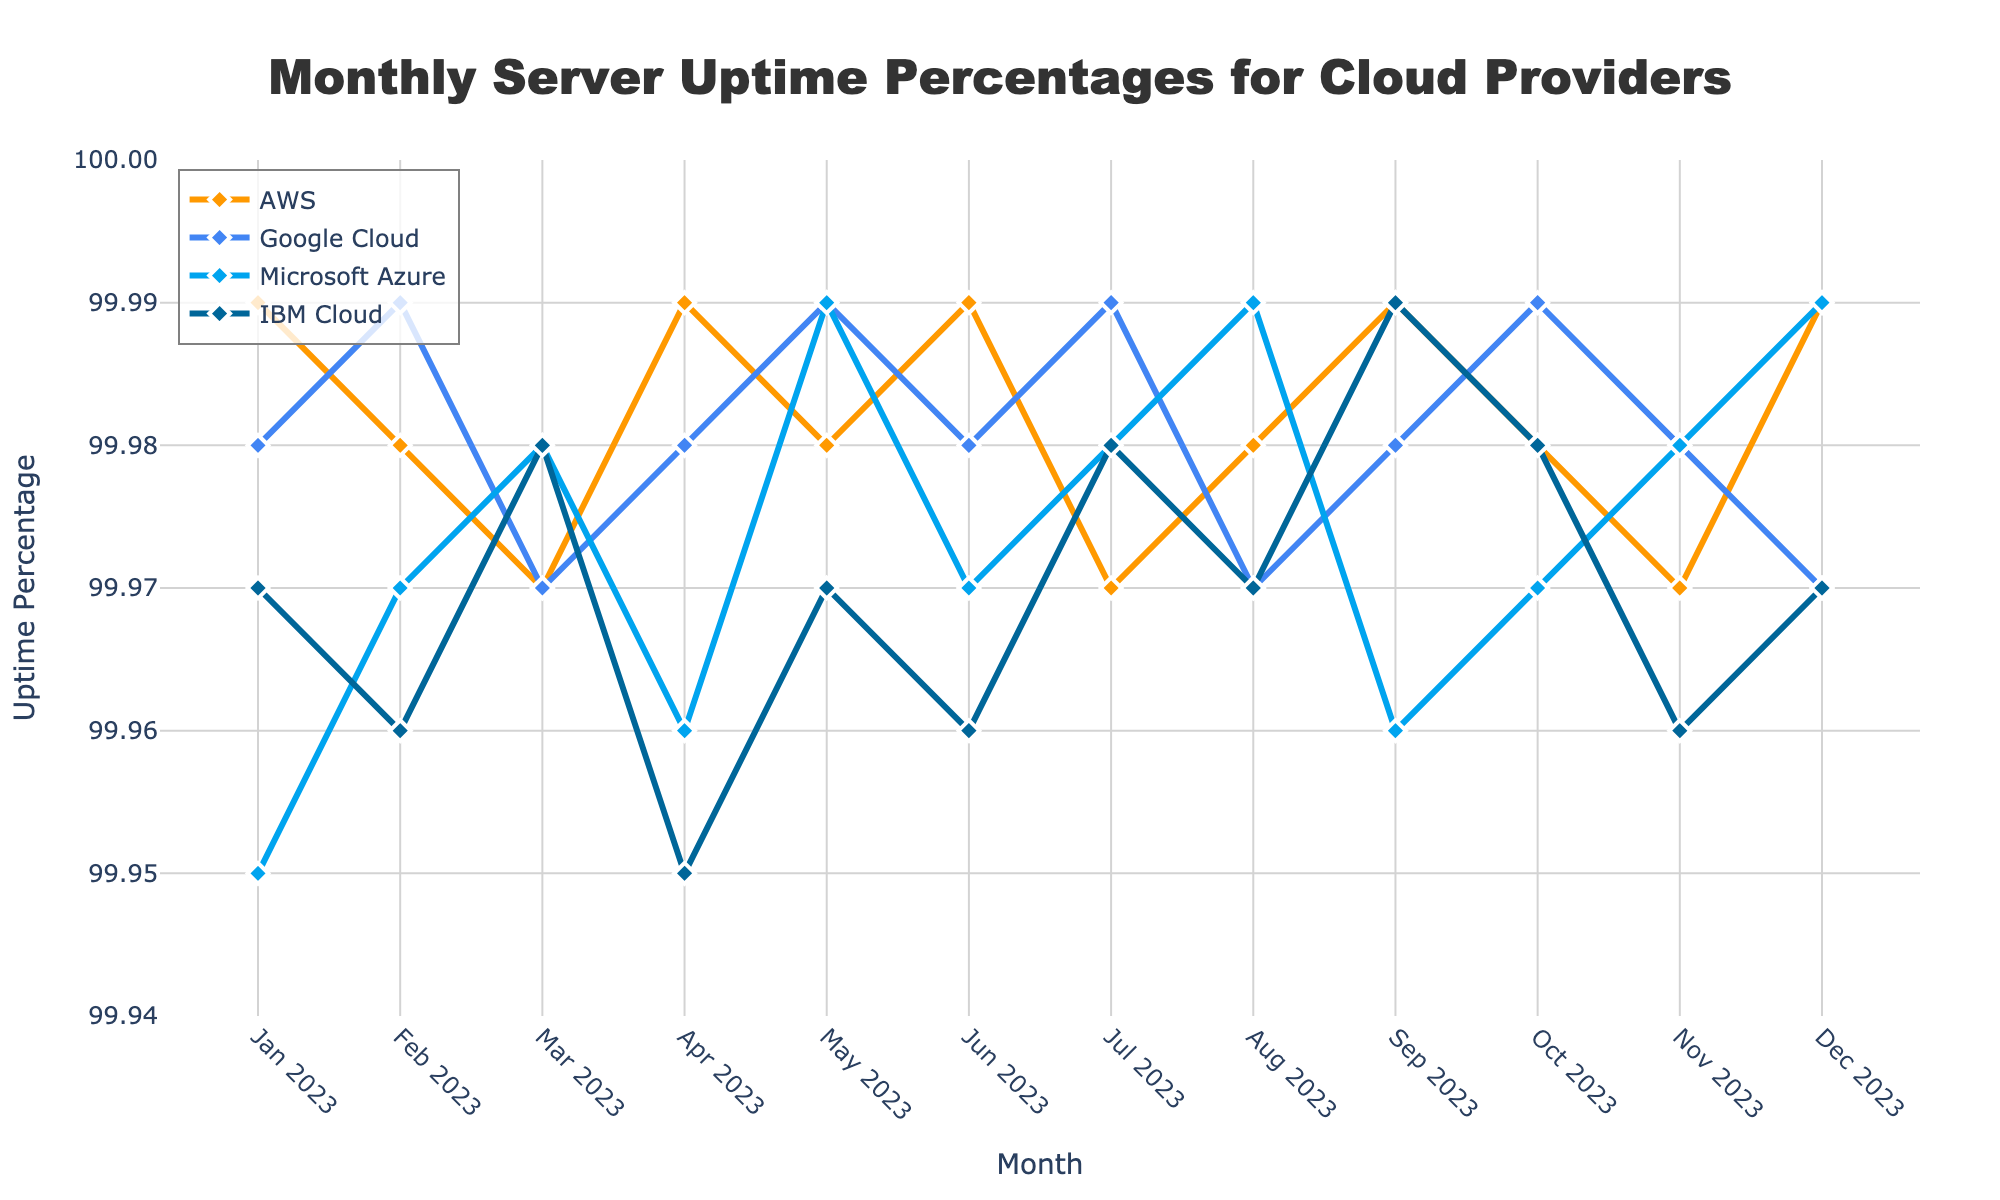What's the highest uptime percentage achieved by Google Cloud? To determine the highest uptime percentage for Google Cloud, visually inspect the plot for the peak point on the Google Cloud line (blue color). According to the dataset, Google Cloud achieved 99.99% uptime in Feb, May, Jul, and Oct of 2023.
Answer: 99.99% Which provider had the highest uptime in January 2023? Look for the January 2023 data points and compare the values of all providers. AWS had an uptime of 99.99%, Google Cloud had 99.98%, Microsoft Azure had 99.95%, and IBM Cloud had 99.97%. AWS had the highest uptime in January 2023.
Answer: AWS Between August and November 2023, which provider showed the greatest decrease in uptime? Check the uptime percentages for each provider from August to November. AWS went from 99.98% to 99.97%, Google Cloud went from 99.97% to 99.98%, Microsoft Azure went from 99.99% to 99.98%, and IBM Cloud went from 99.97% to 99.96%. AWS and IBM Cloud both showed a decrease of 0.01% in uptime.
Answer: AWS and IBM Cloud What was the average uptime percentage for AWS throughout the year? Calculate the average by summing all the monthly uptime percentages for AWS and dividing by the number of months. Sum = 99.99 + 99.98 + 99.97 + 99.99 + 99.98 + 99.99 + 99.97 + 99.98 + 99.99 + 99.98 + 99.97 + 99.99 = 1199.78, and the average is 1199.78 / 12 = 99.982%.
Answer: 99.982% How many months did IBM Cloud have an uptime of 99.98% or higher? Identify the months where IBM Cloud had an uptime percentage of at least 99.98%. From the data, IBM Cloud had 99.98% in Mar, Jul, Sep, and Oct of 2023. Total number of such months is 4.
Answer: 4 Which month had the lowest overall uptime percentage among all providers? Compare the lowest uptime values for each month across all providers to find the lowest one. The lowest uptime percentage is 99.95% in Jan 2023 for Microsoft Azure.
Answer: January 2023 What is the difference in uptime percentage between AWS and Microsoft Azure in May 2023? Look at the May 2023 data points. AWS had 99.98%, and Microsoft Azure had 99.99%. The difference is 99.99% - 99.98% = 0.01%.
Answer: 0.01% Which provider had the most consistent uptime (smallest variation) throughout the year? Compare the range (max - min) of uptime percentages for each provider. The provider with the smallest range has the most consistent uptime. AWS ranges from 99.97% to 99.99% (0.02% range), Google Cloud from 99.97% to 99.99% (0.02% range), Microsoft Azure from 99.95% to 99.99% (0.04% range), and IBM Cloud from 99.95% to 99.99% (0.04% range). Both AWS and Google Cloud have the smallest range.
Answer: AWS and Google Cloud 